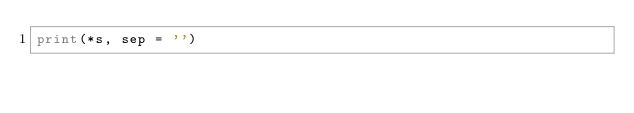<code> <loc_0><loc_0><loc_500><loc_500><_Python_>print(*s, sep = '')</code> 